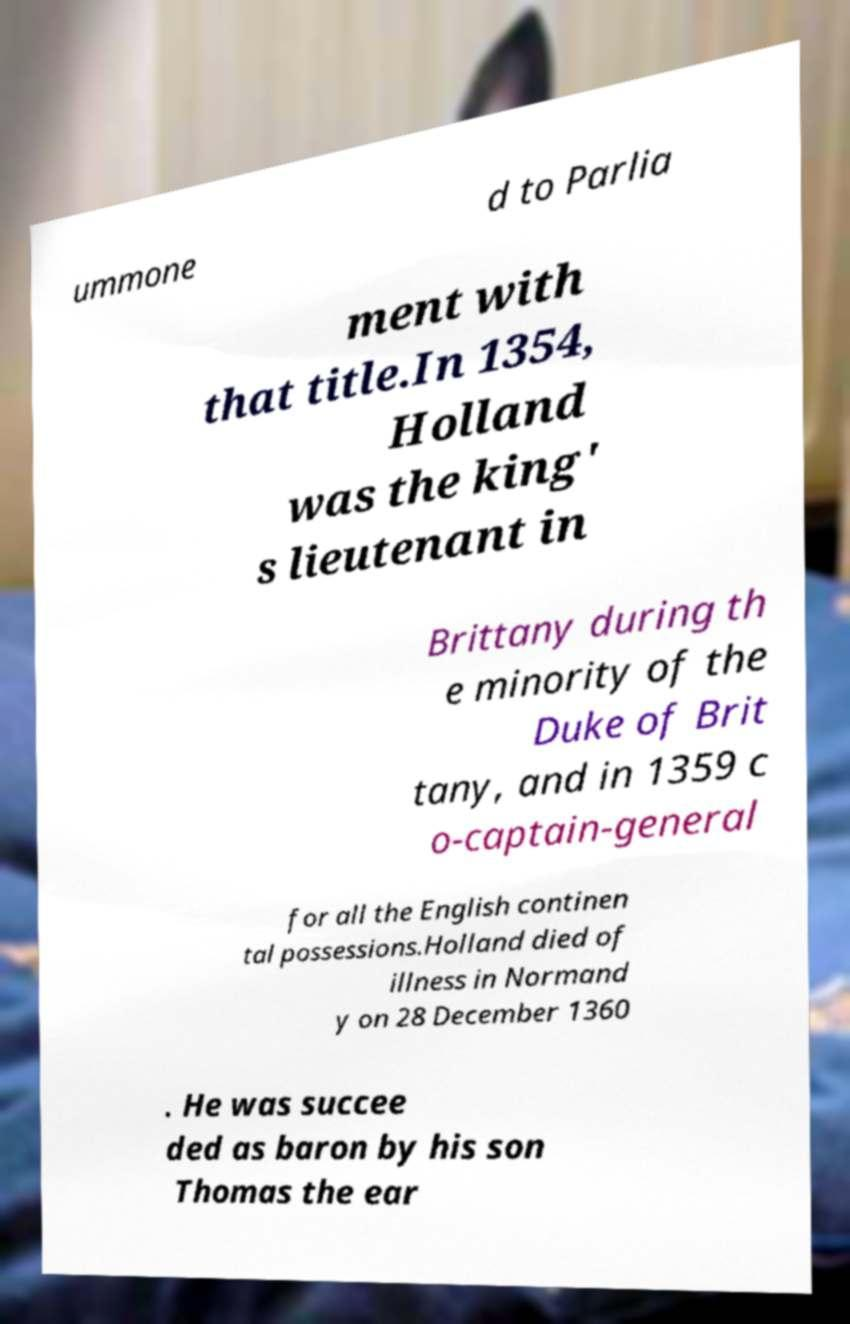I need the written content from this picture converted into text. Can you do that? ummone d to Parlia ment with that title.In 1354, Holland was the king' s lieutenant in Brittany during th e minority of the Duke of Brit tany, and in 1359 c o-captain-general for all the English continen tal possessions.Holland died of illness in Normand y on 28 December 1360 . He was succee ded as baron by his son Thomas the ear 